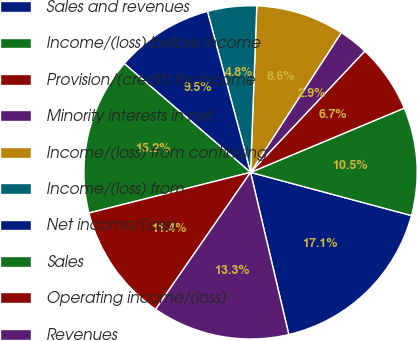<chart> <loc_0><loc_0><loc_500><loc_500><pie_chart><fcel>Sales and revenues<fcel>Income/(loss) before income<fcel>Provision/(credit) for income<fcel>Minority interests in net<fcel>Income/(loss) from continuing<fcel>Income/(loss) from<fcel>Net income/(loss)<fcel>Sales<fcel>Operating income/(loss)<fcel>Revenues<nl><fcel>17.14%<fcel>10.48%<fcel>6.67%<fcel>2.86%<fcel>8.57%<fcel>4.76%<fcel>9.52%<fcel>15.24%<fcel>11.43%<fcel>13.33%<nl></chart> 